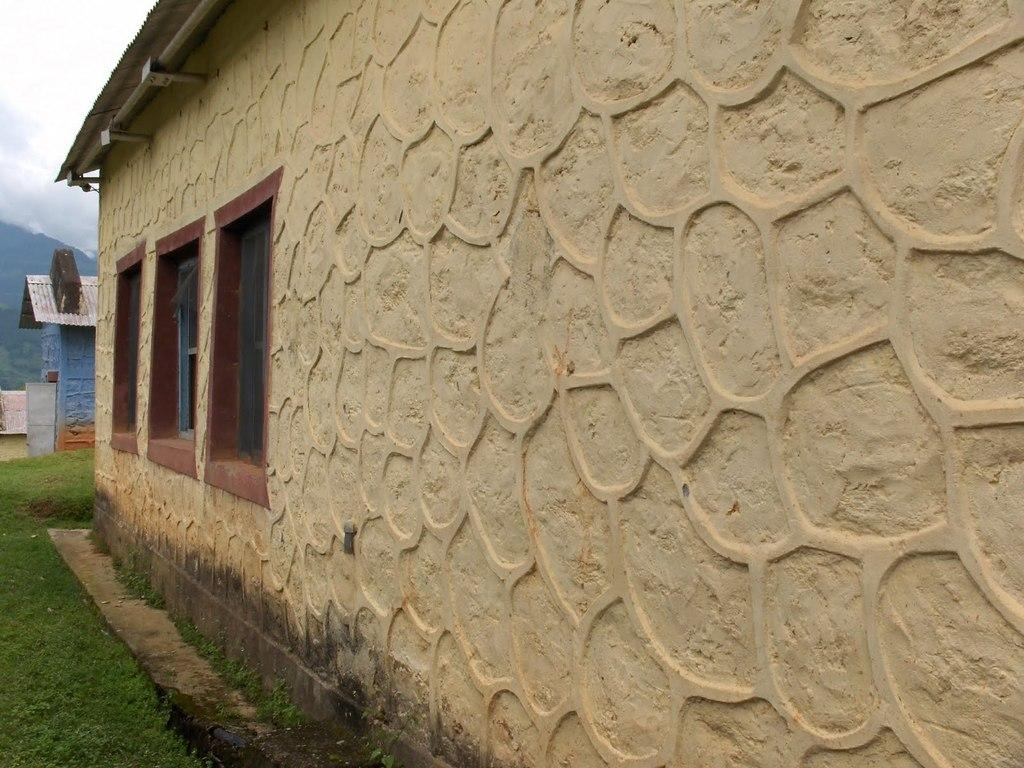What type of structures are present in the image? There are houses in the image. What architectural features can be seen on the houses? There are windows and at least one door visible on the houses. What type of vegetation is present in the image? There is grass in the image. What geographical feature is present in the image? There is a hill in the image. What is visible in the background of the image? The sky is visible in the background of the image. Can you tell me how many mothers are visible in the image? There is no mother present in the image; it features houses, windows, doors, grass, a hill, and the sky. What type of hole can be seen in the image? There is no hole present in the image; it features houses, windows, doors, grass, a hill, and the sky. 